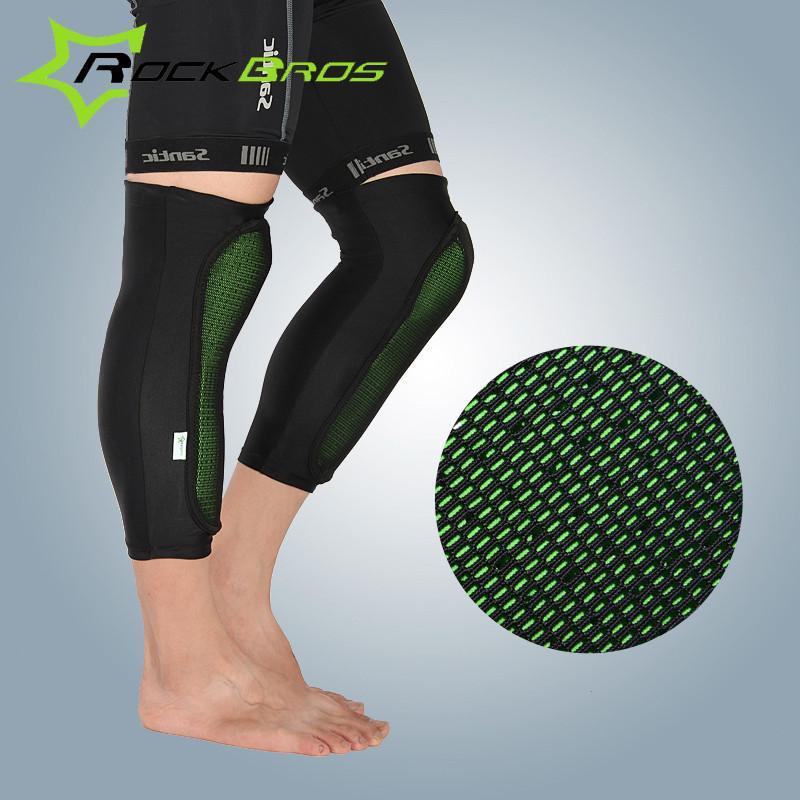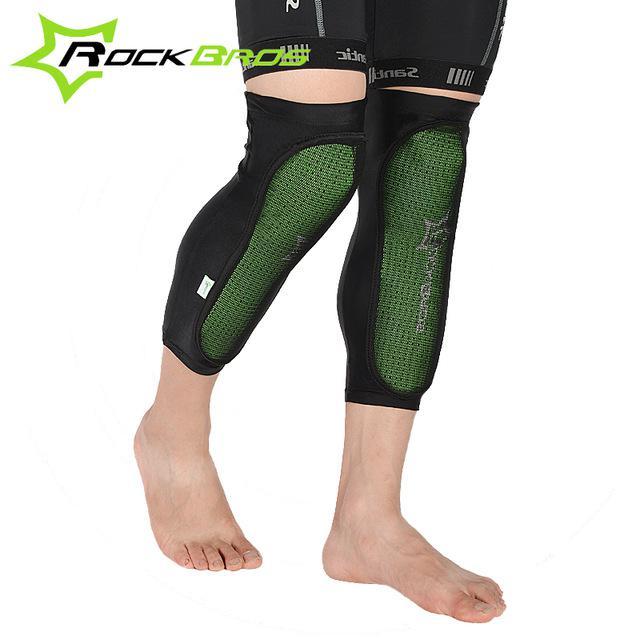The first image is the image on the left, the second image is the image on the right. For the images displayed, is the sentence "There are two pairs of legs and two pairs of leg braces." factually correct? Answer yes or no. Yes. 